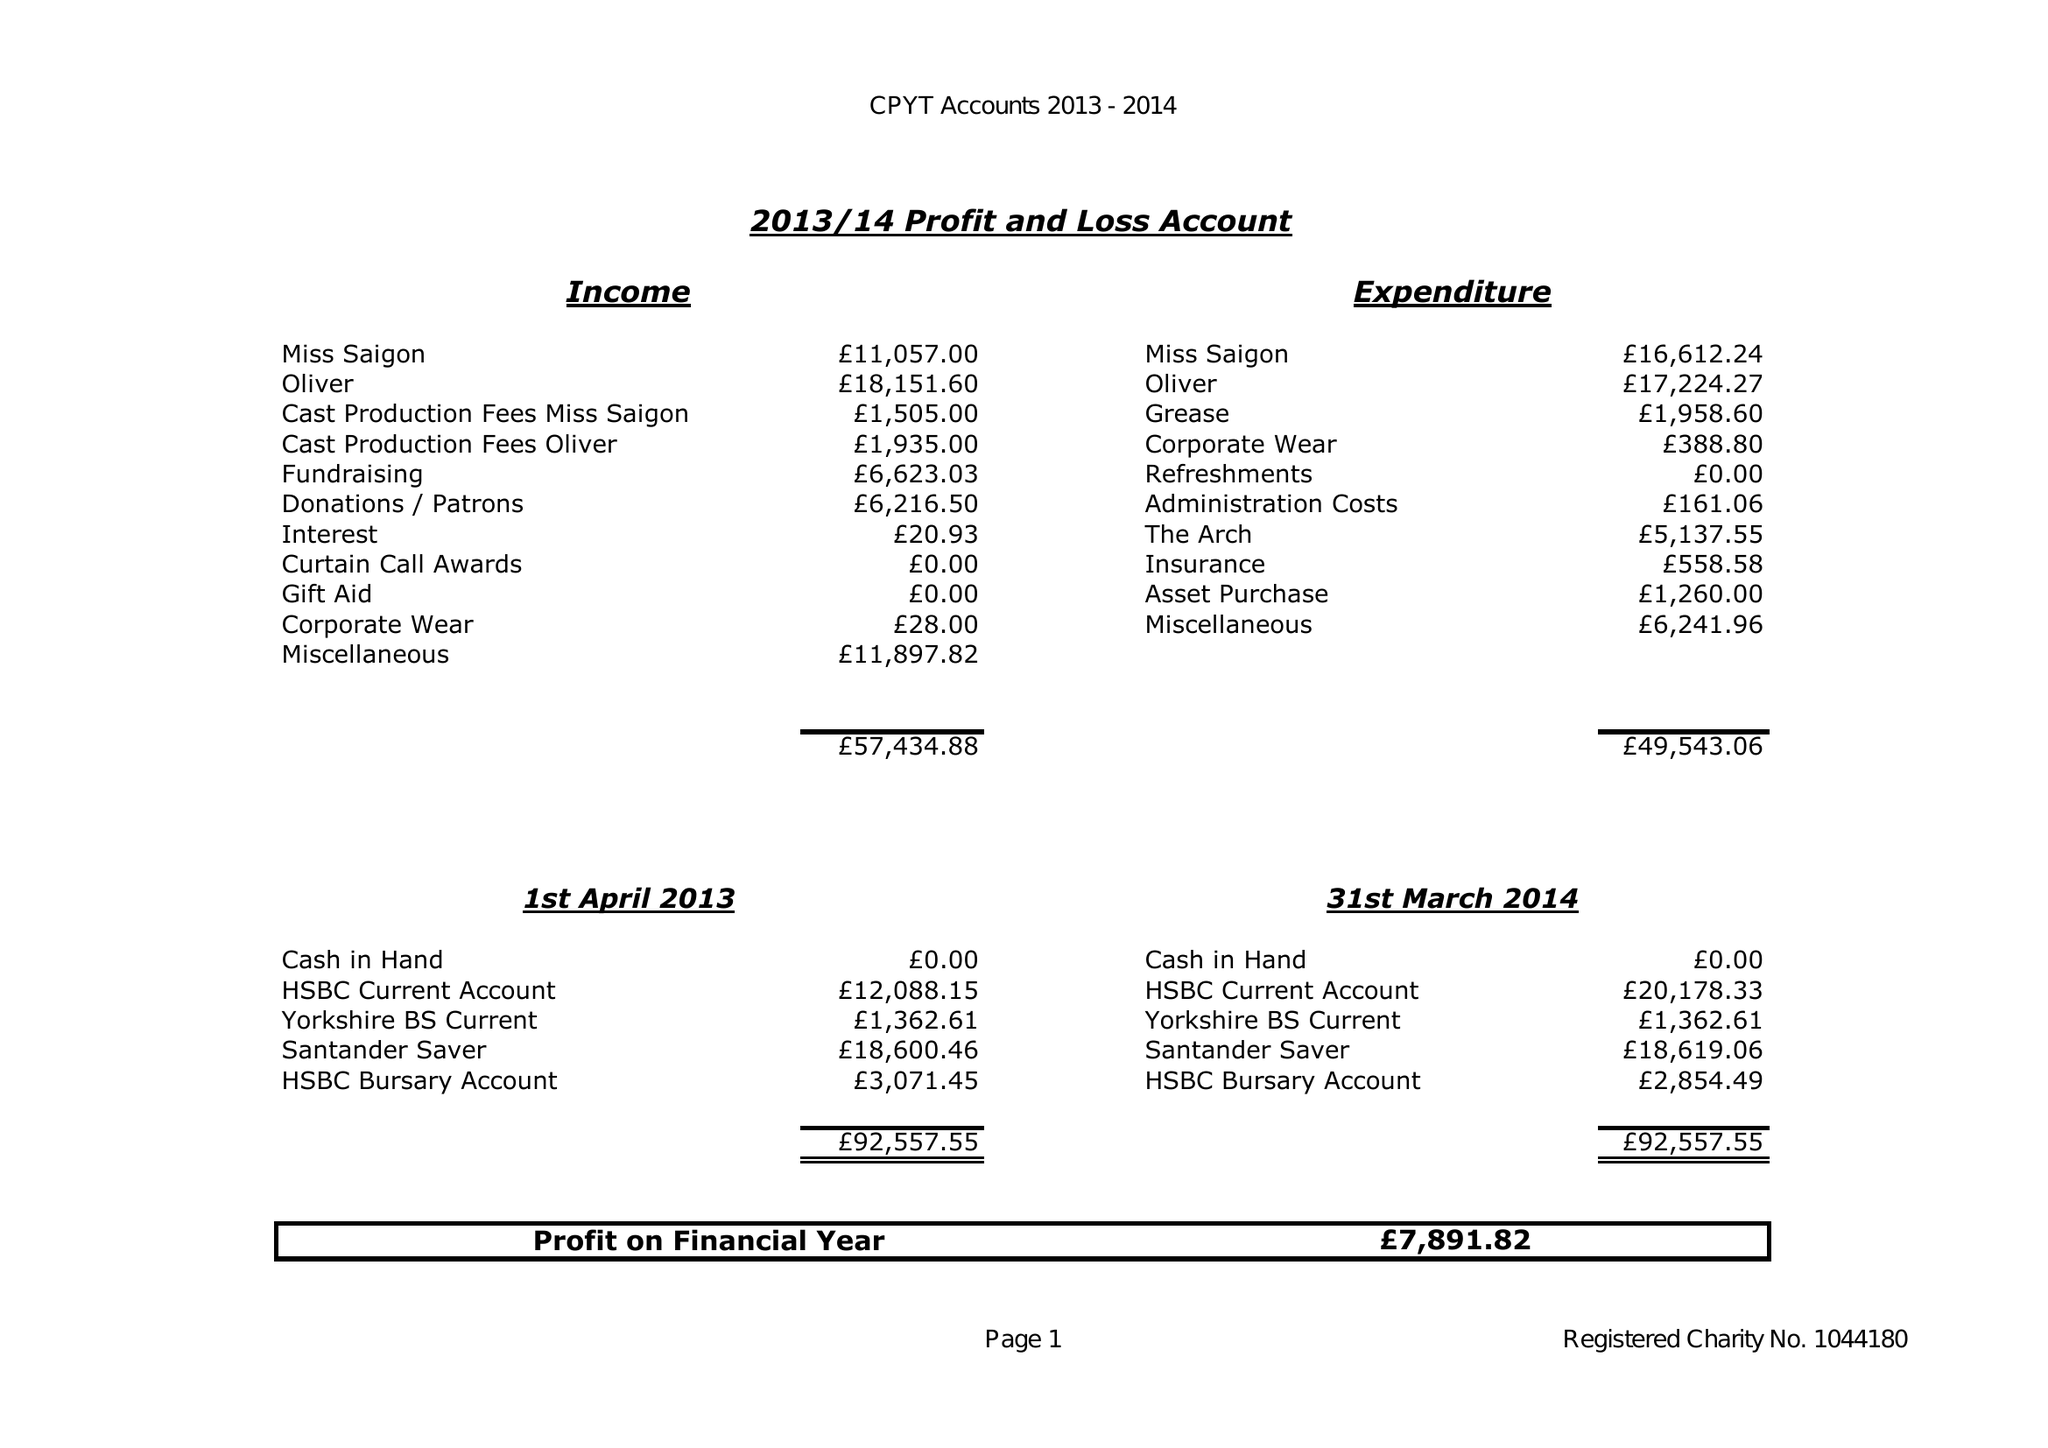What is the value for the charity_number?
Answer the question using a single word or phrase. 1044180 